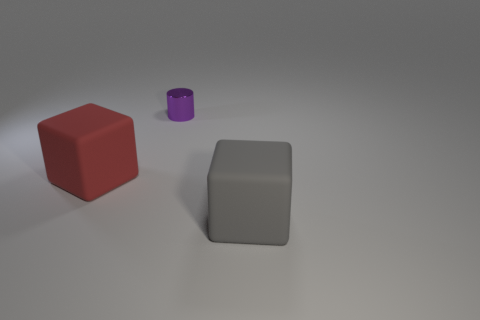Add 1 large metallic cylinders. How many objects exist? 4 Subtract all cylinders. How many objects are left? 2 Subtract 0 brown cylinders. How many objects are left? 3 Subtract all cylinders. Subtract all big things. How many objects are left? 0 Add 2 gray blocks. How many gray blocks are left? 3 Add 1 green objects. How many green objects exist? 1 